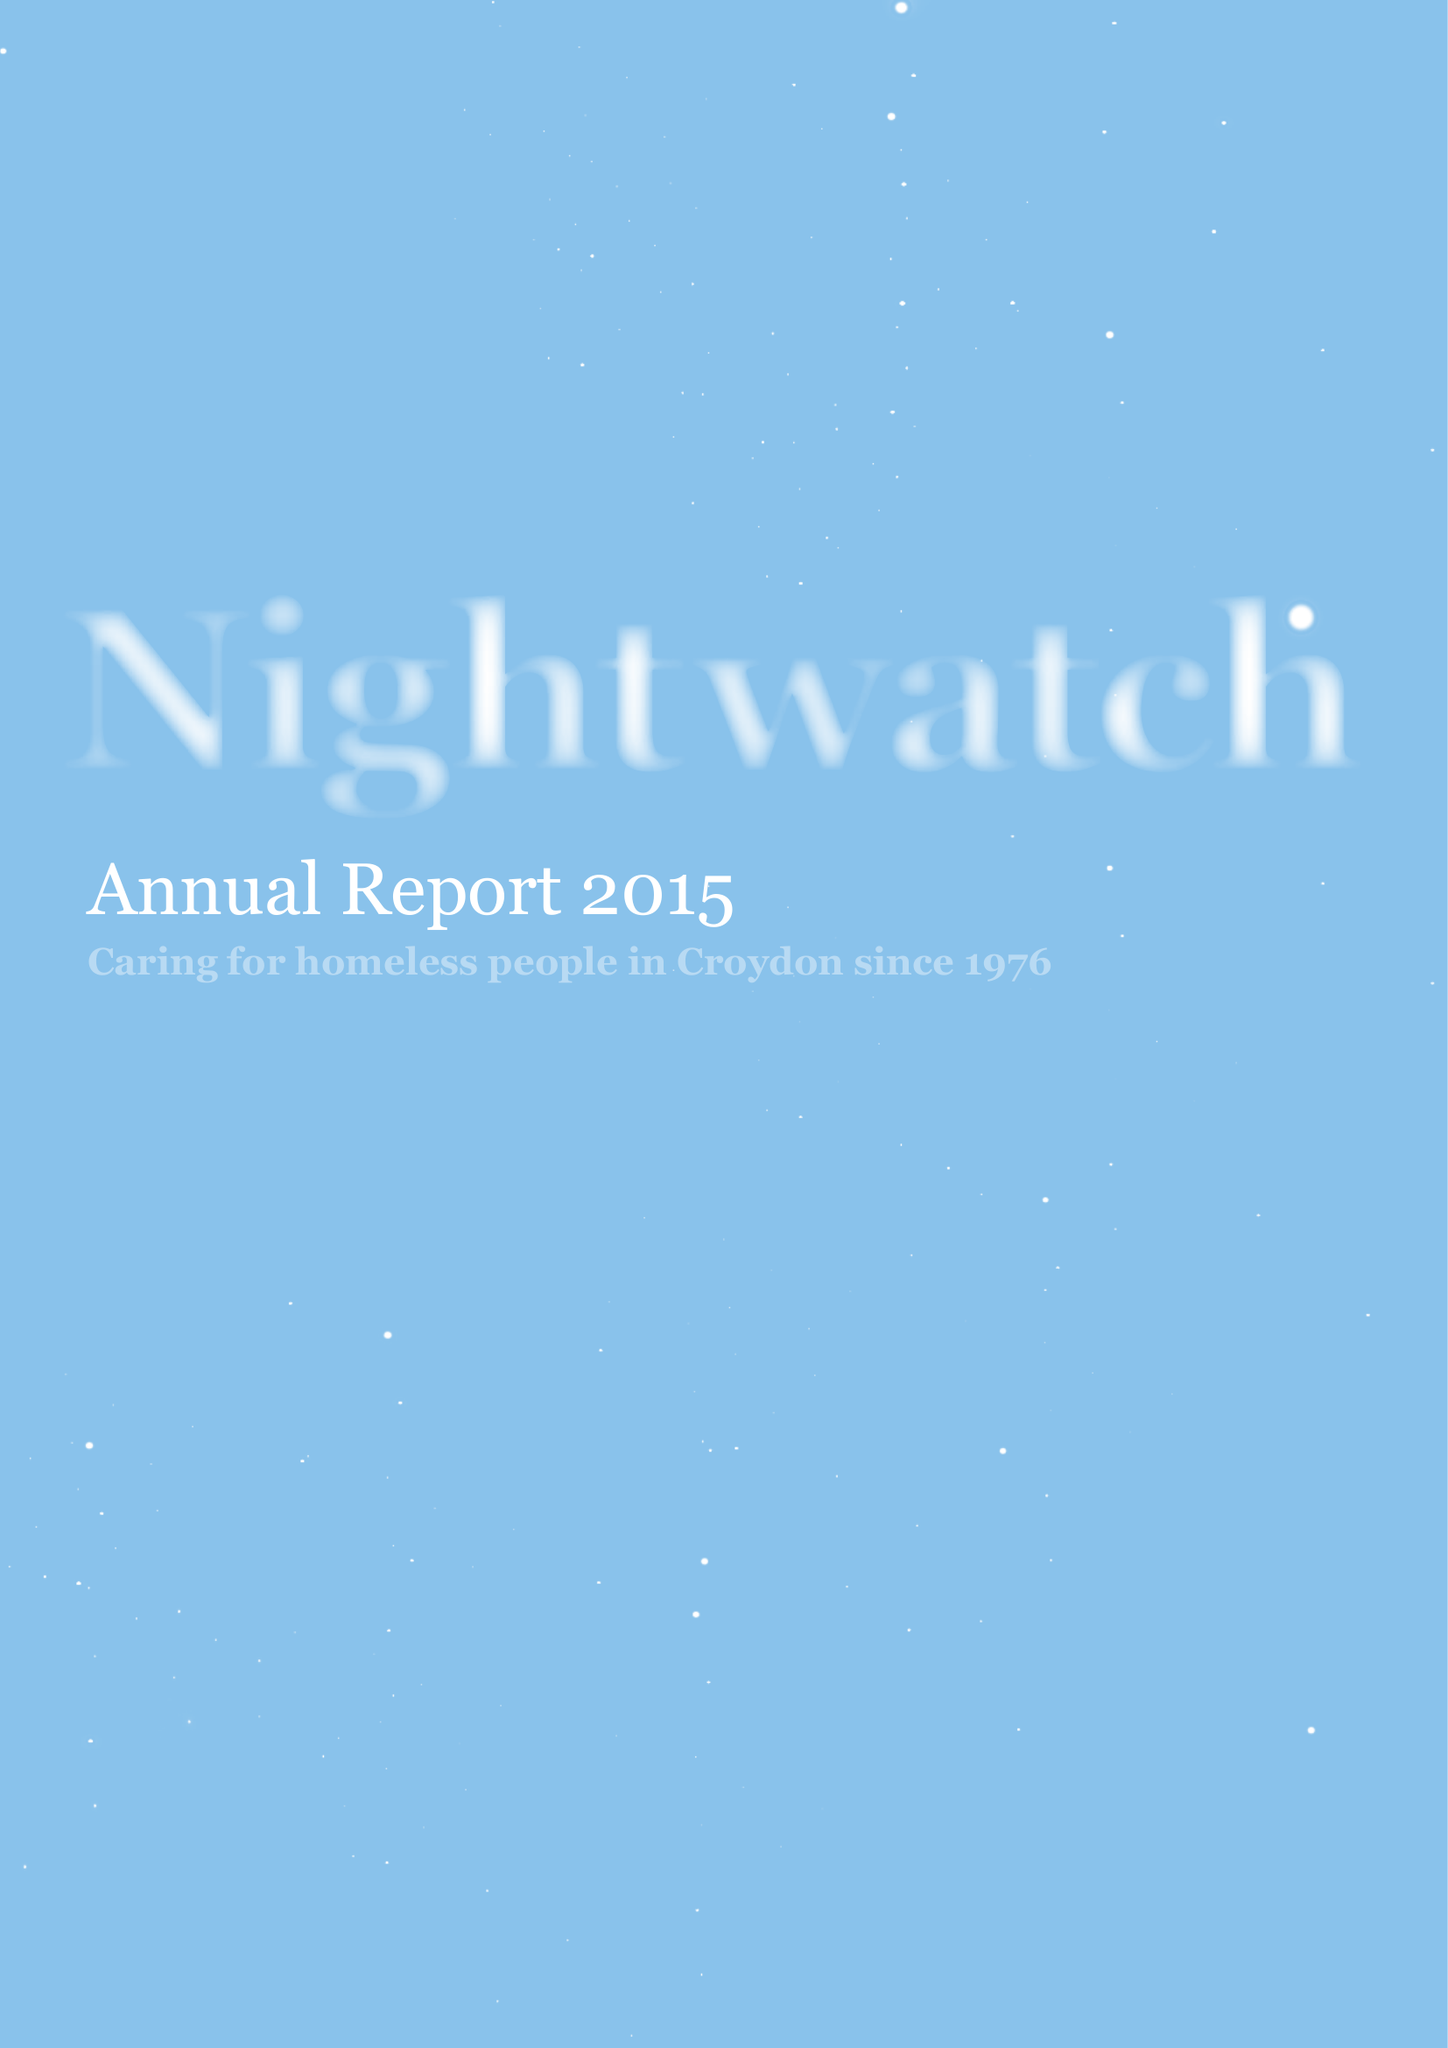What is the value for the address__postcode?
Answer the question using a single word or phrase. SE23 3ZH 